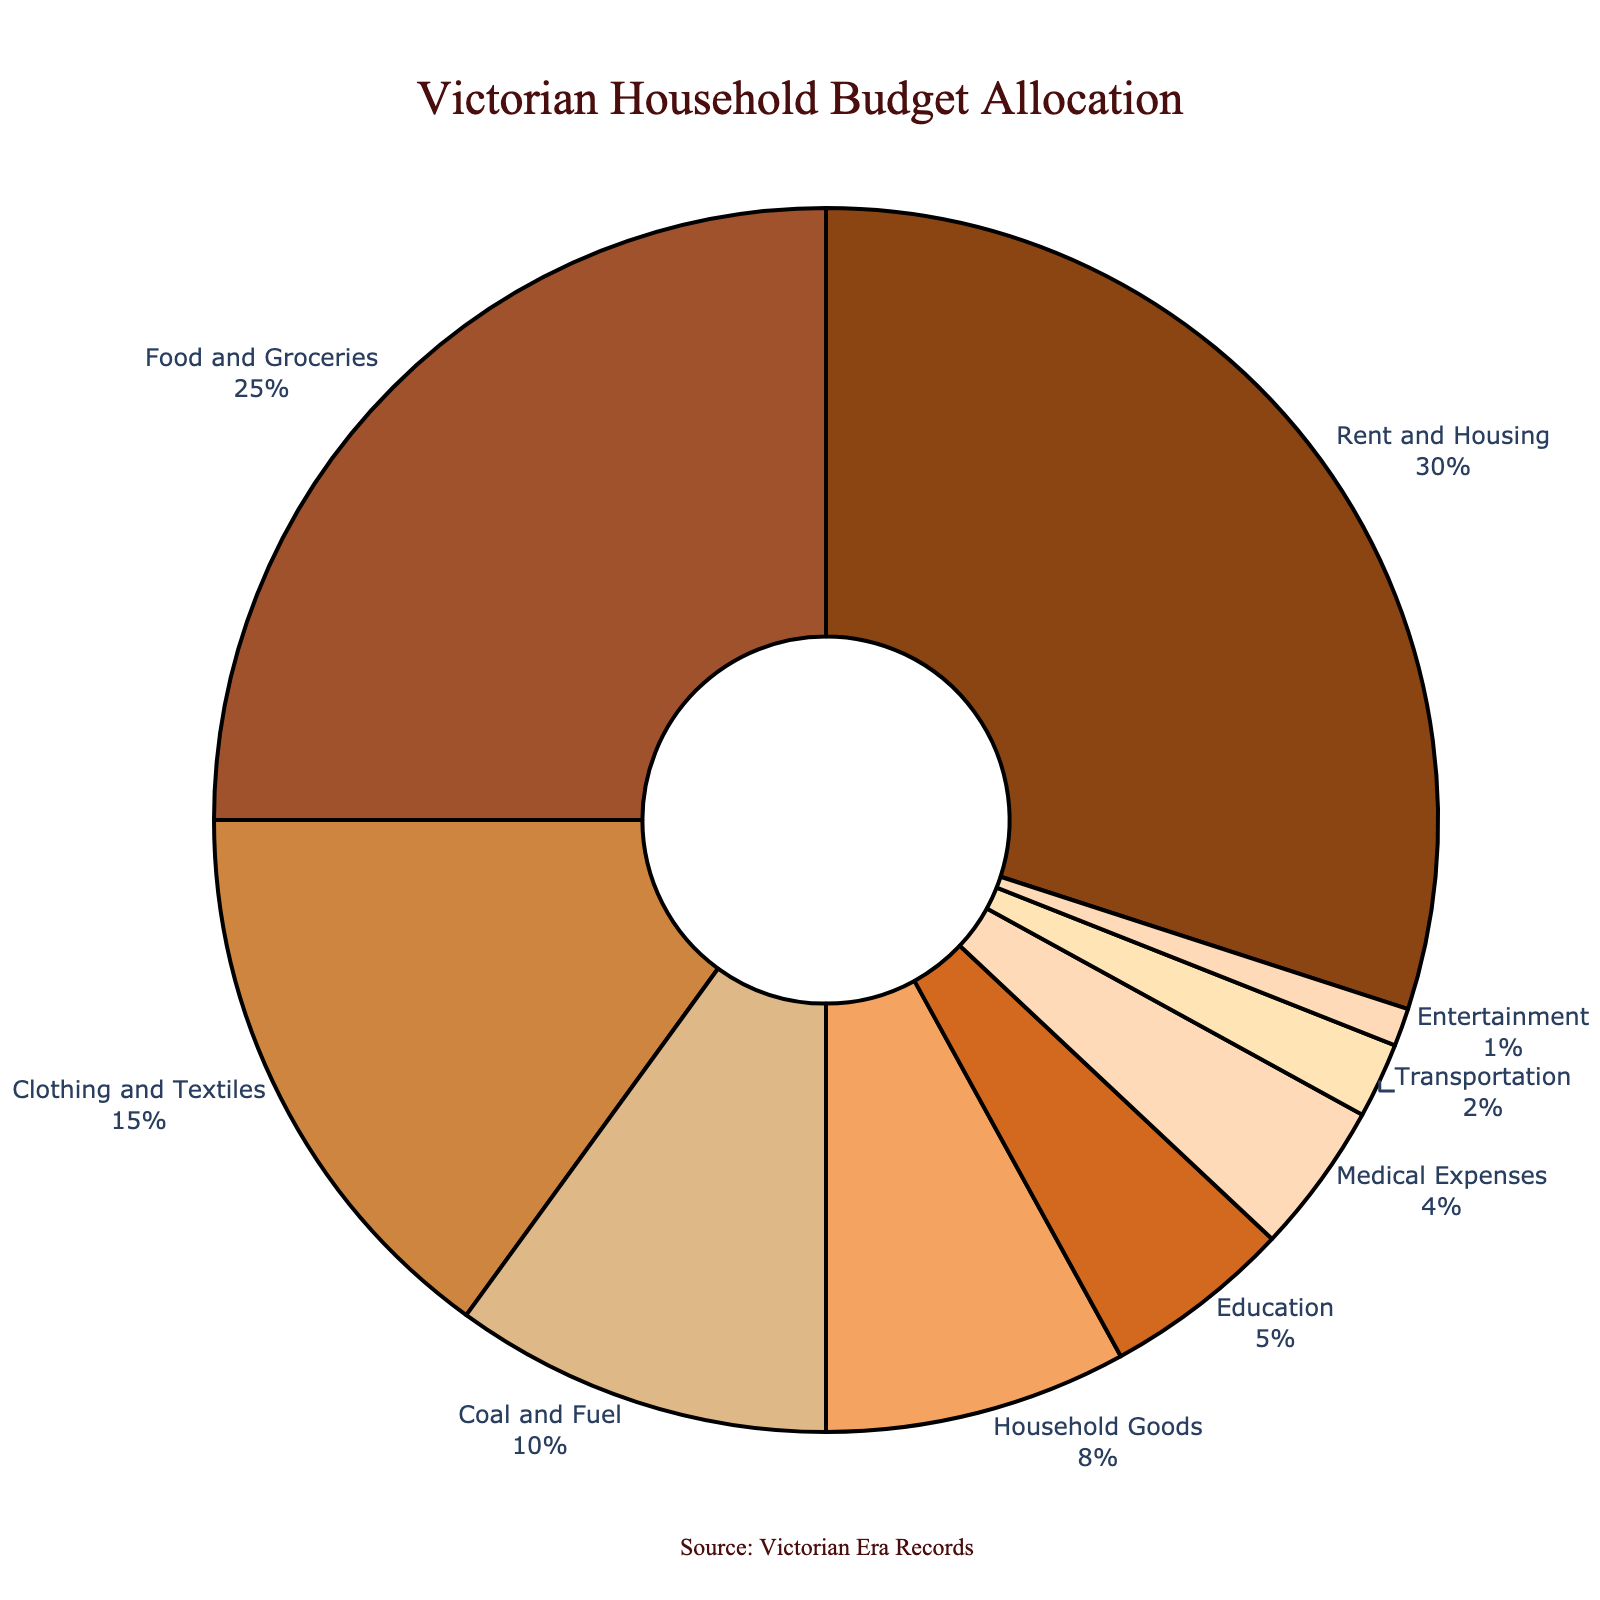What is the largest category in the Victorian household budget allocation? The largest category can be identified by looking at the segment with the highest percentage. According to the pie chart, "Rent and Housing" has the largest share at 30%.
Answer: Rent and Housing Which two categories combined make up exactly 40% of the budget? To find two categories that add up to 40%, we look at individual percentages. "Food and Groceries" at 25% and "Clothing and Textiles" at 15% together add up to 40%.
Answer: Food and Groceries and Clothing and Textiles What is the difference in percentage between "Rent and Housing" and "Food and Groceries"? "Rent and Housing" is 30% and "Food and Groceries" is 25%. The difference is calculated as 30% - 25% = 5%.
Answer: 5% How much more is spent on "Household Goods" compared to "Education"? "Household Goods" is 8% and "Education" is 5%. The difference is 8% - 5% = 3%.
Answer: 3% Which categories together form a quarter of the budget? A quarter of the budget is 25%. "Food and Groceries" alone accounts for 25%. Therefore, this category forms a quarter of the budget.
Answer: Food and Groceries What is the total percentage allocated to non-essential items (Education, Medical Expenses, Transportation, Entertainment)? Adding up the percentages for Education (5%), Medical Expenses (4%), Transportation (2%), and Entertainment (1%) results in 5% + 4% + 2% + 1% = 12%.
Answer: 12% How many categories have a budget allocation greater than 10%? By looking at the pie chart, categories with more than 10% allocation are "Rent and Housing" (30%), "Food and Groceries" (25%), and "Clothing and Textiles" (15%). This totals to three categories.
Answer: 3 What percentage of the budget is allocated to the three smallest categories combined? The three smallest categories are Transportation (2%) and Entertainment (1%). Adding them together results in 2% + 1% = 3%.
Answer: 3% Which category is represented by the darkest color on the pie chart? The darkest color segment on the pie chart is correlated with "Rent and Housing," which has the highest percentage (30%).
Answer: Rent and Housing 